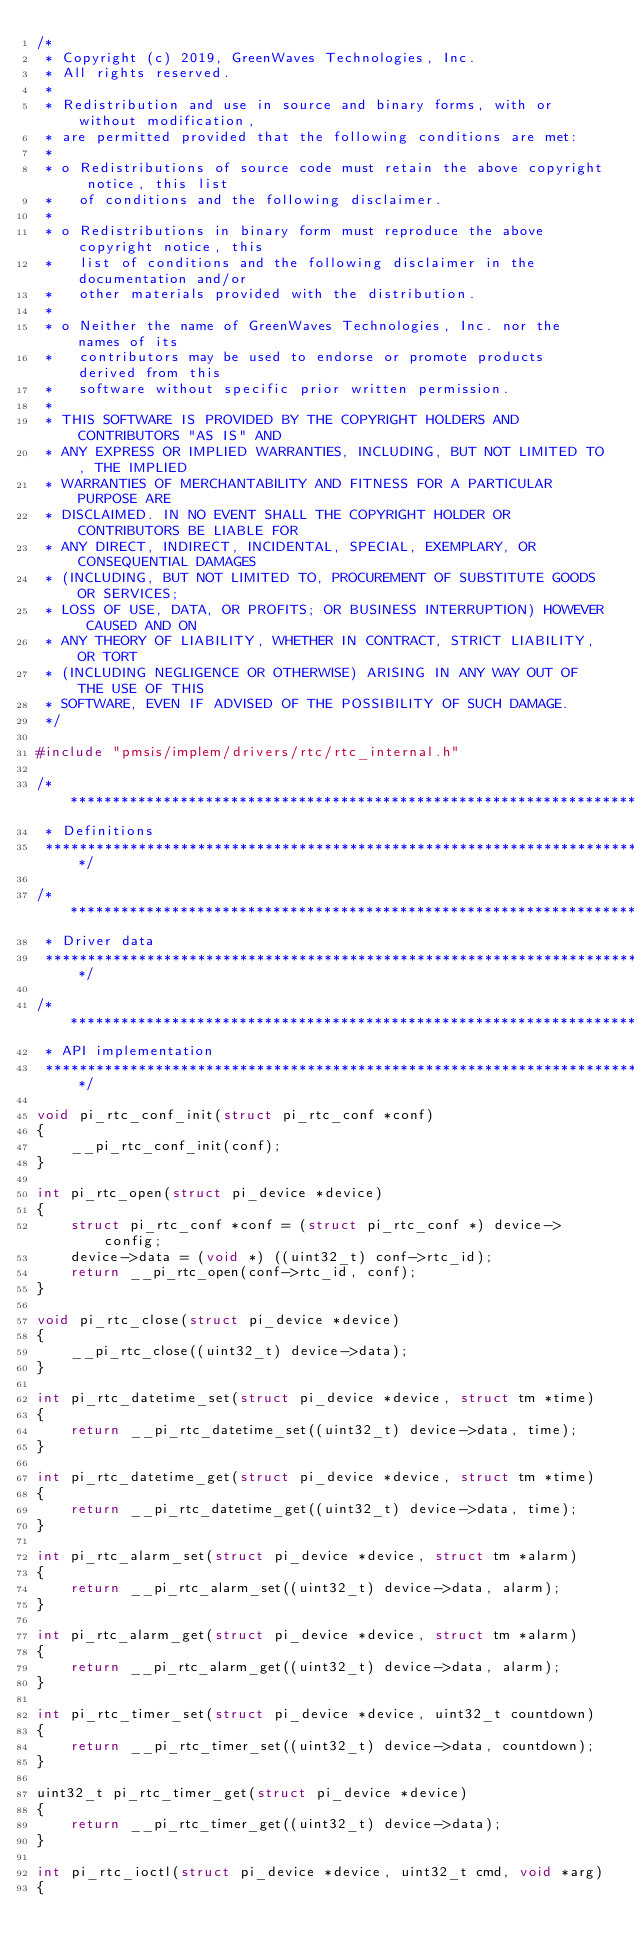<code> <loc_0><loc_0><loc_500><loc_500><_C_>/*
 * Copyright (c) 2019, GreenWaves Technologies, Inc.
 * All rights reserved.
 *
 * Redistribution and use in source and binary forms, with or without modification,
 * are permitted provided that the following conditions are met:
 *
 * o Redistributions of source code must retain the above copyright notice, this list
 *   of conditions and the following disclaimer.
 *
 * o Redistributions in binary form must reproduce the above copyright notice, this
 *   list of conditions and the following disclaimer in the documentation and/or
 *   other materials provided with the distribution.
 *
 * o Neither the name of GreenWaves Technologies, Inc. nor the names of its
 *   contributors may be used to endorse or promote products derived from this
 *   software without specific prior written permission.
 *
 * THIS SOFTWARE IS PROVIDED BY THE COPYRIGHT HOLDERS AND CONTRIBUTORS "AS IS" AND
 * ANY EXPRESS OR IMPLIED WARRANTIES, INCLUDING, BUT NOT LIMITED TO, THE IMPLIED
 * WARRANTIES OF MERCHANTABILITY AND FITNESS FOR A PARTICULAR PURPOSE ARE
 * DISCLAIMED. IN NO EVENT SHALL THE COPYRIGHT HOLDER OR CONTRIBUTORS BE LIABLE FOR
 * ANY DIRECT, INDIRECT, INCIDENTAL, SPECIAL, EXEMPLARY, OR CONSEQUENTIAL DAMAGES
 * (INCLUDING, BUT NOT LIMITED TO, PROCUREMENT OF SUBSTITUTE GOODS OR SERVICES;
 * LOSS OF USE, DATA, OR PROFITS; OR BUSINESS INTERRUPTION) HOWEVER CAUSED AND ON
 * ANY THEORY OF LIABILITY, WHETHER IN CONTRACT, STRICT LIABILITY, OR TORT
 * (INCLUDING NEGLIGENCE OR OTHERWISE) ARISING IN ANY WAY OUT OF THE USE OF THIS
 * SOFTWARE, EVEN IF ADVISED OF THE POSSIBILITY OF SUCH DAMAGE.
 */

#include "pmsis/implem/drivers/rtc/rtc_internal.h"

/*******************************************************************************
 * Definitions
 ******************************************************************************/

/*******************************************************************************
 * Driver data
 ******************************************************************************/

/*******************************************************************************
 * API implementation
 ******************************************************************************/

void pi_rtc_conf_init(struct pi_rtc_conf *conf)
{
    __pi_rtc_conf_init(conf);
}

int pi_rtc_open(struct pi_device *device)
{
    struct pi_rtc_conf *conf = (struct pi_rtc_conf *) device->config;
    device->data = (void *) ((uint32_t) conf->rtc_id);
    return __pi_rtc_open(conf->rtc_id, conf);
}

void pi_rtc_close(struct pi_device *device)
{
    __pi_rtc_close((uint32_t) device->data);
}

int pi_rtc_datetime_set(struct pi_device *device, struct tm *time)
{
    return __pi_rtc_datetime_set((uint32_t) device->data, time);
}

int pi_rtc_datetime_get(struct pi_device *device, struct tm *time)
{
    return __pi_rtc_datetime_get((uint32_t) device->data, time);
}

int pi_rtc_alarm_set(struct pi_device *device, struct tm *alarm)
{
    return __pi_rtc_alarm_set((uint32_t) device->data, alarm);
}

int pi_rtc_alarm_get(struct pi_device *device, struct tm *alarm)
{
    return __pi_rtc_alarm_get((uint32_t) device->data, alarm);
}

int pi_rtc_timer_set(struct pi_device *device, uint32_t countdown)
{
    return __pi_rtc_timer_set((uint32_t) device->data, countdown);
}

uint32_t pi_rtc_timer_get(struct pi_device *device)
{
    return __pi_rtc_timer_get((uint32_t) device->data);
}

int pi_rtc_ioctl(struct pi_device *device, uint32_t cmd, void *arg)
{</code> 